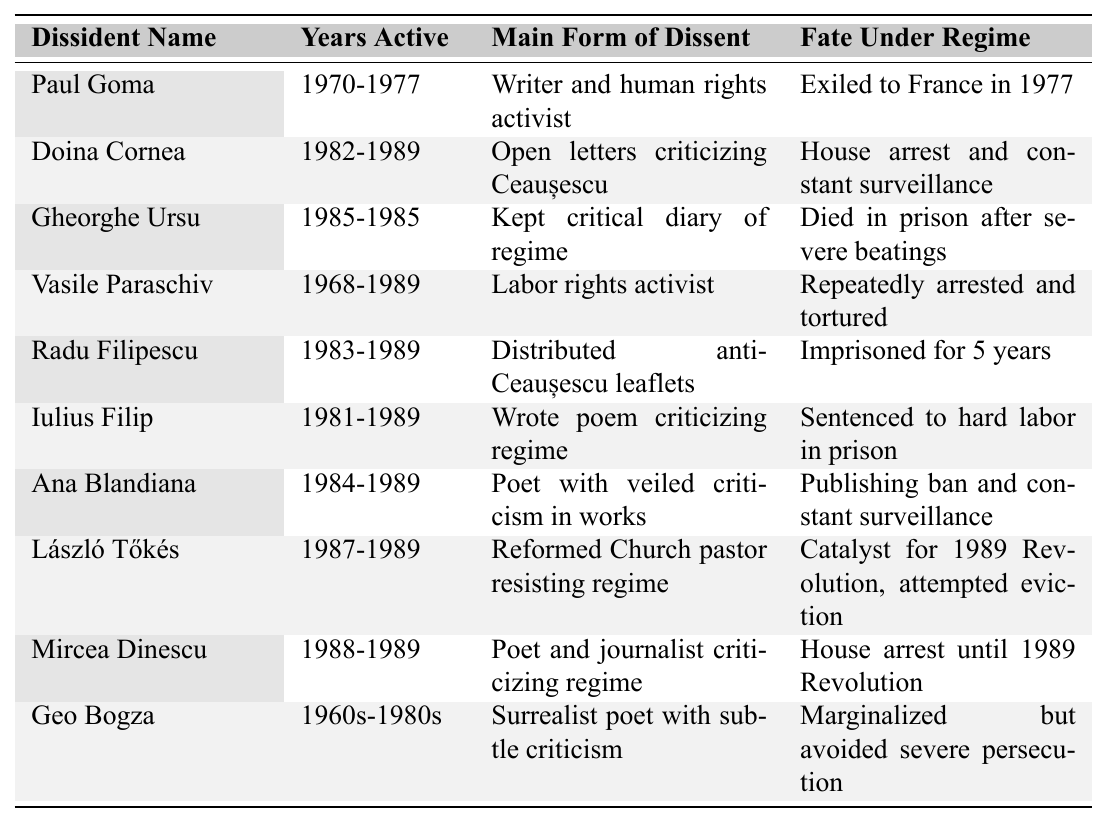What is the fate of Paul Goma under the Communist regime? According to the table, Paul Goma was exiled to France in 1977.
Answer: Exiled to France in 1977 Which dissident was known for writing poems that included veiled criticism of the regime? The table indicates that Ana Blandiana was a poet with veiled criticism in her works.
Answer: Ana Blandiana How many dissidents were imprisoned for their activities? From the table, Radu Filipescu was imprisoned for 5 years, Iulius Filip was sentenced to hard labor in prison, and Gheorghe Ursu died in prison after severe beatings. Therefore, there are two distinct cases of imprisonment (Radu Filipescu and Iulius Filip).
Answer: 2 Was Mircea Dinescu in house arrest after the 1989 Revolution? The table states that Mircea Dinescu was in house arrest until the 1989 Revolution, which means he was not in house arrest after the revolution.
Answer: No What is the average duration of activity among the listed dissidents? To find the average, consider the active years for each dissident: Paul Goma (7), Doina Cornea (7), Gheorghe Ursu (1), Vasile Paraschiv (21), Radu Filipescu (6), Iulius Filip (8), Ana Blandiana (5), László Tőkés (2), Mircea Dinescu (1), and Geo Bogza (20). The total is 7 + 7 + 1 + 21 + 6 + 8 + 5 + 2 + 1 + 20 = 78, divided by 10 (the number of dissidents), gives the average duration of 7.8 years.
Answer: 7.8 years Which dissident actively distributed anti-Ceaușescu leaflets? According to the table, Radu Filipescu distributed anti-Ceaușescu leaflets.
Answer: Radu Filipescu Among the dissidents listed, who faced constant surveillance? The table mentions that both Doina Cornea and Ana Blandiana experienced constant surveillance.
Answer: Doina Cornea and Ana Blandiana What were the main forms of dissent practiced by Vasile Paraschiv? From the table, Vasile Paraschiv was primarily a labor rights activist.
Answer: Labor rights activist Which two dissidents had their fate related to the 1989 Revolution? The table states that László Tőkés was a catalyst for the 1989 Revolution and Mircea Dinescu was under house arrest until afterward.
Answer: László Tőkés and Mircea Dinescu 